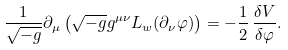Convert formula to latex. <formula><loc_0><loc_0><loc_500><loc_500>\frac { 1 } { \sqrt { - g } } \partial _ { \mu } \left ( \sqrt { - g } g ^ { \mu \nu } L _ { w } ( \partial _ { \nu } \varphi ) \right ) = - \frac { 1 } { 2 } \, \frac { \delta V } { \delta \varphi } .</formula> 